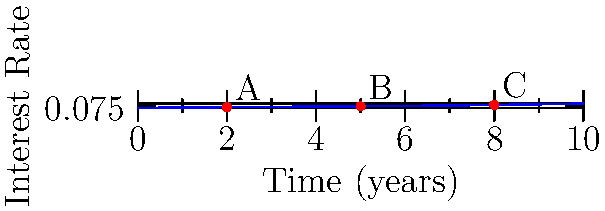Given the interest rate curve modeled by a cubic spline interpolation as shown in the graph, where points A, B, and C represent known data points at years 2, 5, and 8 respectively, calculate the approximate interest rate at year 6 using linear interpolation between points B and C. Express your answer as a percentage rounded to two decimal places. To solve this problem, we'll follow these steps:

1) Identify the known points:
   Point B: (5, f(5))
   Point C: (8, f(8))

2) Calculate f(5) and f(8):
   $f(x) = 0.02 + 0.01x - 0.001x^2 + 0.0001x^3$
   
   $f(5) = 0.02 + 0.01(5) - 0.001(5^2) + 0.0001(5^3)$
         $= 0.02 + 0.05 - 0.025 + 0.00625$
         $= 0.05125$

   $f(8) = 0.02 + 0.01(8) - 0.001(8^2) + 0.0001(8^3)$
         $= 0.02 + 0.08 - 0.064 + 0.0512$
         $= 0.0872$

3) Use linear interpolation formula:
   $f(6) \approx f(5) + \frac{f(8) - f(5)}{8 - 5} \cdot (6 - 5)$

4) Substitute the values:
   $f(6) \approx 0.05125 + \frac{0.0872 - 0.05125}{3} \cdot 1$
         $= 0.05125 + 0.01198333...$
         $= 0.06323333...$

5) Convert to percentage and round to two decimal places:
   $6.32\%$
Answer: 6.32% 